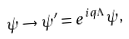<formula> <loc_0><loc_0><loc_500><loc_500>\psi \rightarrow \psi ^ { \prime } = e ^ { i q \Lambda } \psi ,</formula> 